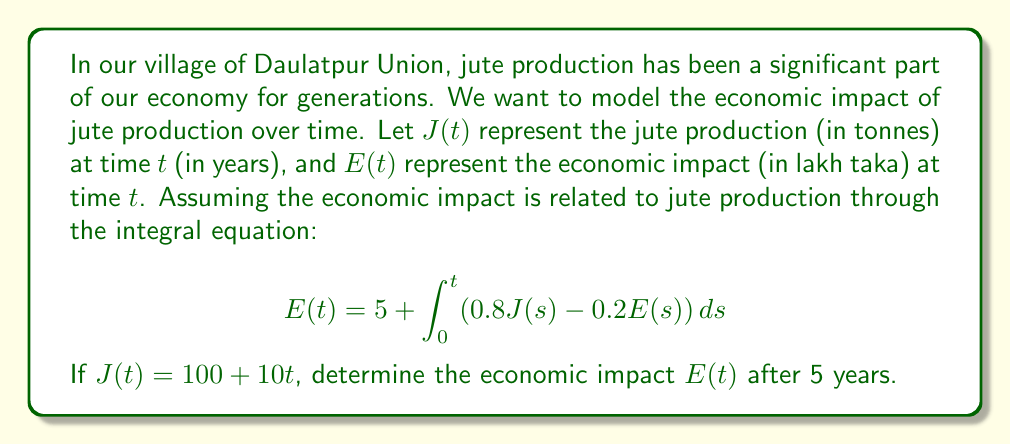Can you solve this math problem? To solve this integral equation, we'll follow these steps:

1) First, we need to differentiate both sides of the equation with respect to $t$:

   $$\frac{dE}{dt} = 0.8J(t) - 0.2E(t)$$

2) Substitute $J(t) = 100 + 10t$ into this equation:

   $$\frac{dE}{dt} = 0.8(100 + 10t) - 0.2E(t)$$
   $$\frac{dE}{dt} = 80 + 8t - 0.2E(t)$$

3) This is a first-order linear differential equation. We can solve it using the integrating factor method. The integrating factor is:

   $$\mu(t) = e^{\int 0.2 dt} = e^{0.2t}$$

4) Multiply both sides of the equation by $\mu(t)$:

   $$e^{0.2t}\frac{dE}{dt} + 0.2e^{0.2t}E = (80 + 8t)e^{0.2t}$$

5) The left side is now the derivative of $e^{0.2t}E$. Integrate both sides:

   $$e^{0.2t}E = \int (80 + 8t)e^{0.2t} dt$$

6) Solve the integral on the right side:

   $$e^{0.2t}E = 80\int e^{0.2t} dt + 8\int te^{0.2t} dt$$
   $$e^{0.2t}E = 400e^{0.2t} + 8(\frac{5t-1}{0.2}e^{0.2t}) + C$$

7) Divide both sides by $e^{0.2t}$:

   $$E(t) = 400 + 40t - 40 + Ce^{-0.2t}$$

8) Use the initial condition $E(0) = 5$ to find $C$:

   $$5 = 400 - 40 + C$$
   $$C = -355$$

9) Therefore, the general solution is:

   $$E(t) = 360 + 40t - 355e^{-0.2t}$$

10) To find $E(5)$, substitute $t = 5$:

    $$E(5) = 360 + 40(5) - 355e^{-0.2(5)}$$
    $$E(5) = 360 + 200 - 355e^{-1}$$
    $$E(5) \approx 560 - 130.5 = 429.5$$
Answer: 429.5 lakh taka 